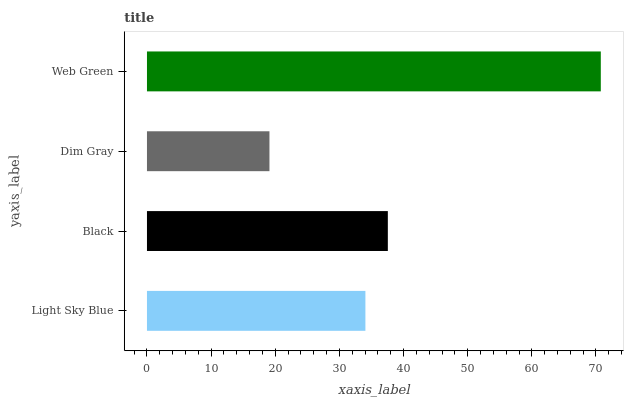Is Dim Gray the minimum?
Answer yes or no. Yes. Is Web Green the maximum?
Answer yes or no. Yes. Is Black the minimum?
Answer yes or no. No. Is Black the maximum?
Answer yes or no. No. Is Black greater than Light Sky Blue?
Answer yes or no. Yes. Is Light Sky Blue less than Black?
Answer yes or no. Yes. Is Light Sky Blue greater than Black?
Answer yes or no. No. Is Black less than Light Sky Blue?
Answer yes or no. No. Is Black the high median?
Answer yes or no. Yes. Is Light Sky Blue the low median?
Answer yes or no. Yes. Is Web Green the high median?
Answer yes or no. No. Is Web Green the low median?
Answer yes or no. No. 